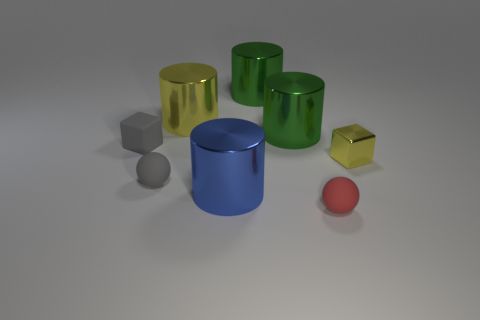There is a cylinder that is in front of the green metallic cylinder in front of the shiny cylinder that is to the left of the blue metallic cylinder; how big is it?
Keep it short and to the point. Large. There is a large cylinder that is in front of the rubber cube; is its color the same as the small shiny block?
Offer a very short reply. No. There is a yellow shiny object that is the same shape as the blue object; what size is it?
Give a very brief answer. Large. How many things are either cylinders in front of the small rubber block or tiny matte things that are on the left side of the yellow cylinder?
Ensure brevity in your answer.  3. What is the shape of the gray thing in front of the small cube that is left of the blue cylinder?
Your answer should be compact. Sphere. Are there any other things of the same color as the tiny metal cube?
Keep it short and to the point. Yes. How many things are either small blue metal spheres or tiny cubes?
Ensure brevity in your answer.  2. Is there a brown metallic cylinder of the same size as the gray cube?
Give a very brief answer. No. What is the shape of the tiny yellow object?
Ensure brevity in your answer.  Cube. Is the number of yellow metal things that are in front of the yellow cylinder greater than the number of shiny cubes that are in front of the tiny shiny thing?
Your response must be concise. Yes. 